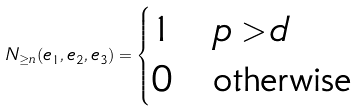<formula> <loc_0><loc_0><loc_500><loc_500>N _ { \geq n } ( e _ { 1 } , e _ { 2 } , e _ { 3 } ) = \begin{cases} 1 & p > d \\ 0 & \text {otherwise} \end{cases}</formula> 